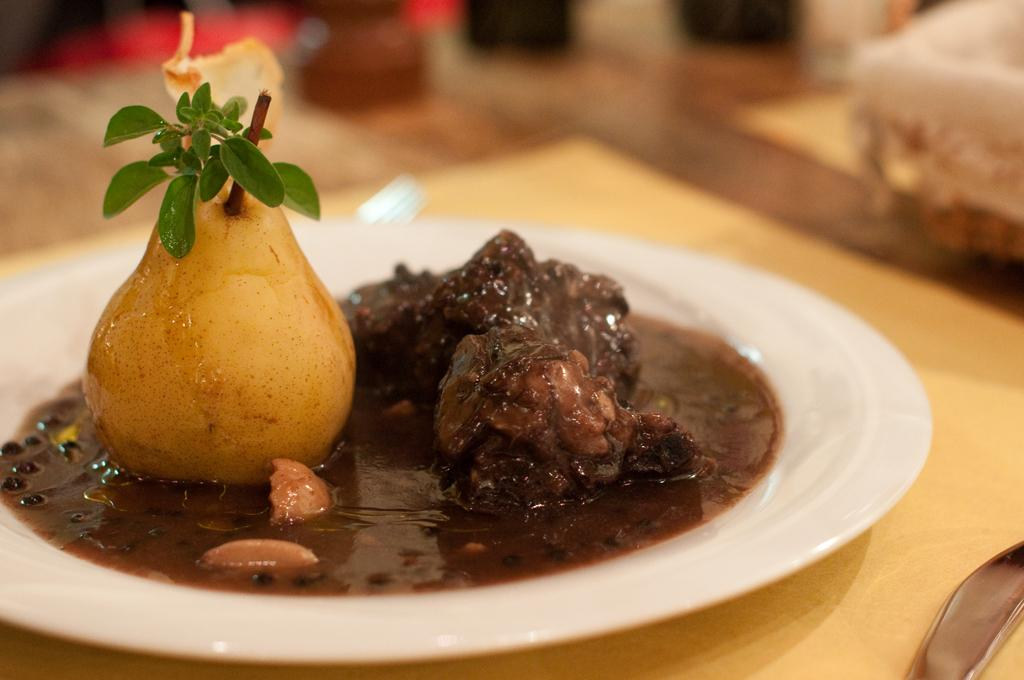What is the main object in the center of the image? There is a table in the center of the image. What is placed on the table? There is a plate on the table. What can be seen on the table besides the plate? There are food items and other objects on the table. What is the price of the ice on the table? There is no ice present on the table in the image, so it is not possible to determine the price. 